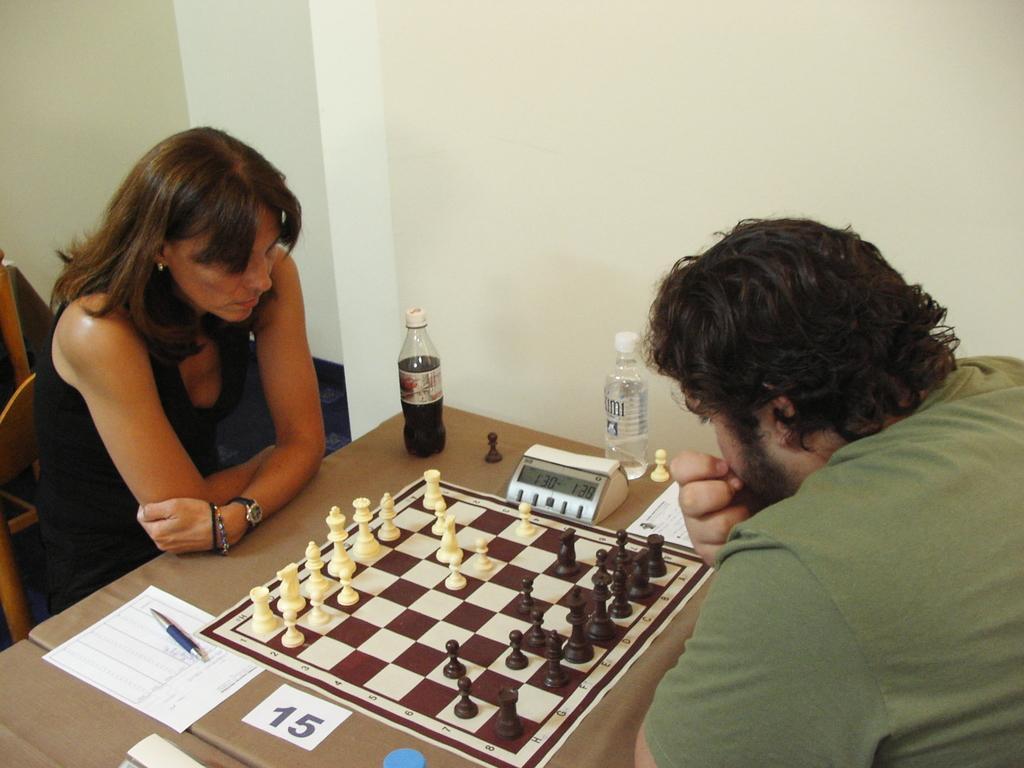Describe this image in one or two sentences. In the center of the image we can see two persons are sitting on the chairs. Between them, we can see a table. On the table, we can see the papers, bottles, one chess board with chess coins and some objects. In the background there is a wall and one wooden object. 